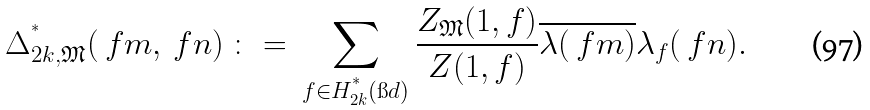Convert formula to latex. <formula><loc_0><loc_0><loc_500><loc_500>\Delta _ { 2 k , \mathfrak { M } } ^ { ^ { * } } ( \ f m , \ f n ) \ \colon = \ \sum _ { f \in H _ { 2 k } ^ { ^ { * } } ( \i d ) } \frac { Z _ { \mathfrak { M } } ( 1 , f ) } { Z ( 1 , f ) } \overline { \lambda ( \ f m ) } \lambda _ { f } ( \ f n ) .</formula> 